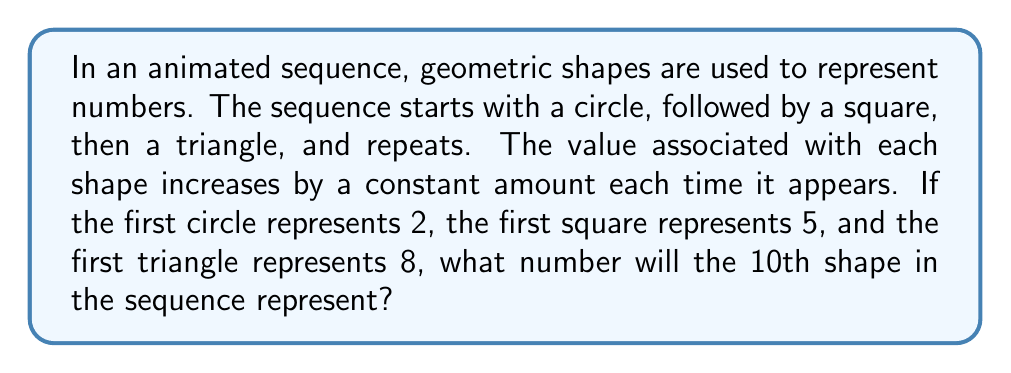Could you help me with this problem? Let's break this down step-by-step:

1) First, let's identify the pattern of shapes:
   Circle (2), Square (5), Triangle (8), Circle, Square, Triangle, ...

2) We can see that the sequence of shapes repeats every 3 terms.

3) Let's look at the number pattern:
   2, 5, 8, ...

4) The difference between each term is constant:
   5 - 2 = 3
   8 - 5 = 3

5) So, each time a shape reappears, its value increases by 9 (3 * 3).

6) To find the 10th shape, we need to determine:
   a) Which shape it will be
   b) How many complete cycles have occurred before it

7) To find which shape:
   10 ÷ 3 = 3 remainder 1
   So, the 10th shape will be a circle (like the 1st, 4th, 7th, etc.)

8) Number of complete cycles:
   $\lfloor \frac{10-1}{3} \rfloor = 3$ cycles

9) The value of the circle:
   Initial value: 2
   Increase: 9 * 3 = 27
   Final value: 2 + 27 = 29

Therefore, the 10th shape in the sequence will represent the number 29.
Answer: 29 